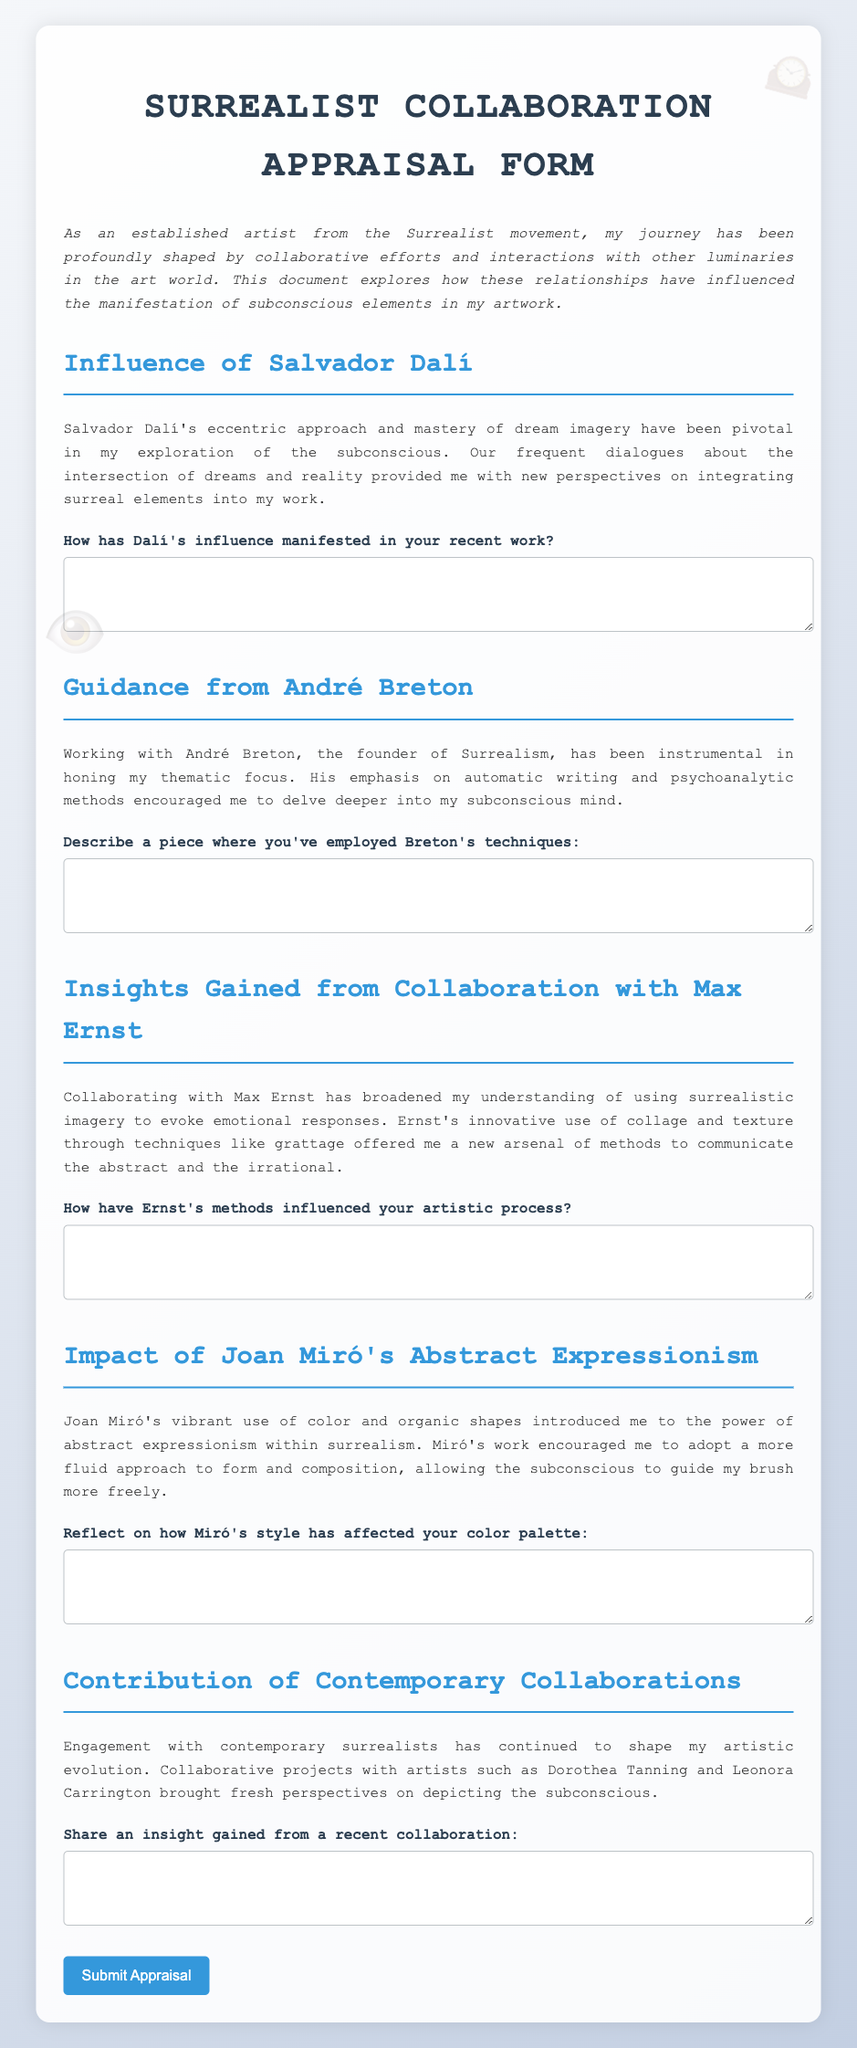What is the title of the form? The title of the form is prominently displayed at the top of the document.
Answer: Surrealist Collaboration Appraisal Form Who is mentioned as a mentor in the influence section? The document refers to specific individuals who have provided guidance or influence, one of which is prominently mentioned.
Answer: André Breton How many artists are discussed in the form? The document includes sections dedicated to various artists, which can be counted.
Answer: Five What technique did Max Ernst use that is mentioned in the document? The document describes specific techniques used by Max Ernst that influenced the artist's work.
Answer: Grattage Which artist is associated with the vibrant use of color? The document attributes a specific quality to one of the artists depicted in the text.
Answer: Joan Miró What type of writing technique did André Breton emphasize? The document specifies a particular method that Breton promoted among artists.
Answer: Automatic writing What does Salvador Dalí's approach focus on according to the document? The document highlights an essential thematic element of Dalí's work.
Answer: Dream imagery What insight does the artist gain from contemporary collaborations? The document summarizes the ongoing influence of contemporary artists on the artist's evolution.
Answer: Fresh perspectives How does Miró's style affect the artist's approach? The document states an effect on the artist's practice relating to forms and colors based on Miró's influence.
Answer: More fluid approach 